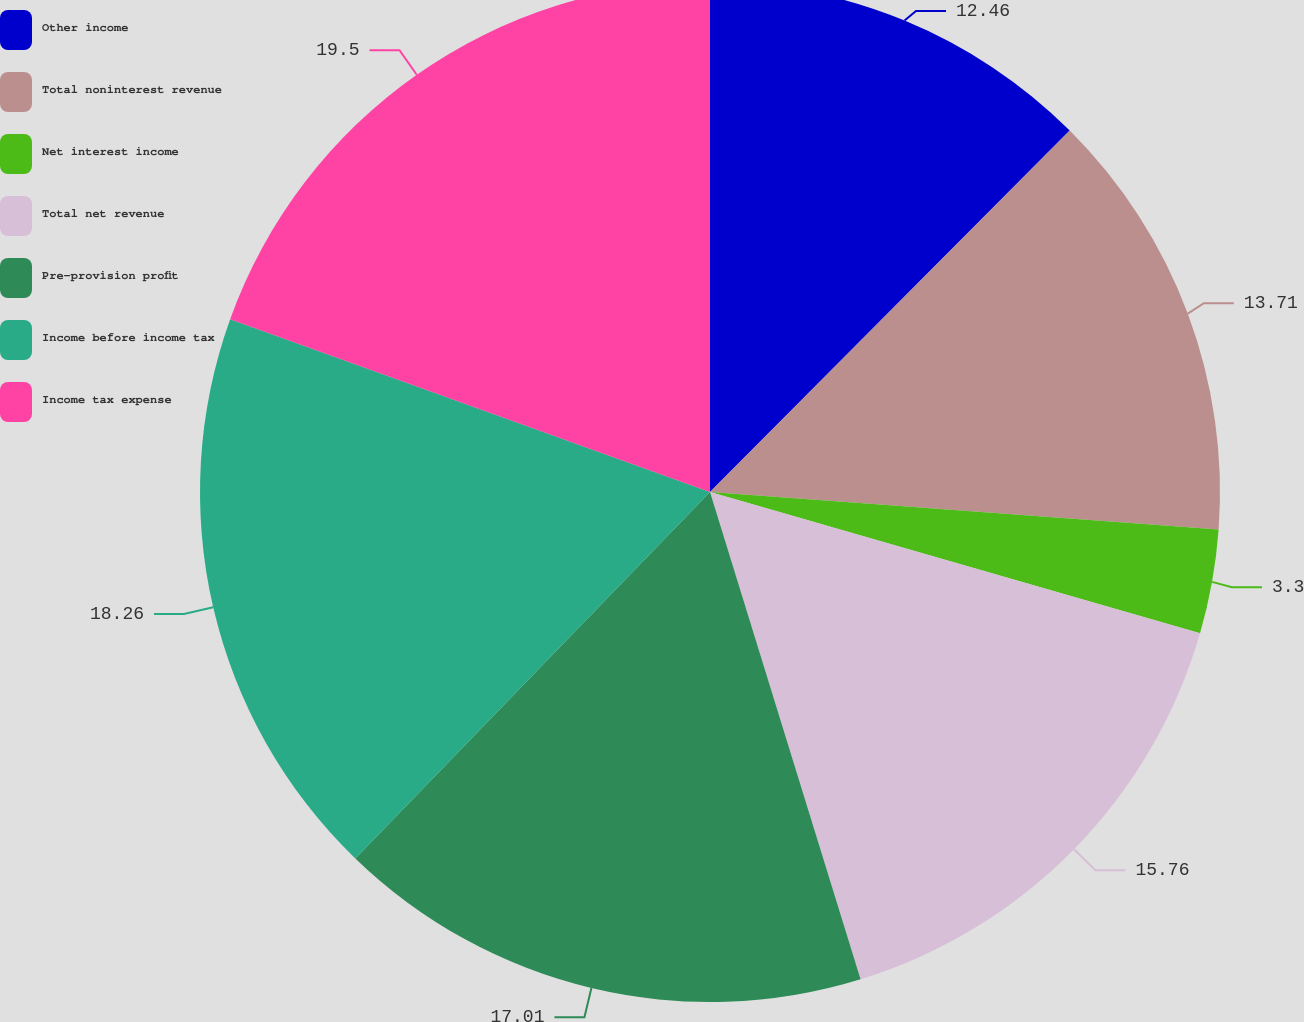<chart> <loc_0><loc_0><loc_500><loc_500><pie_chart><fcel>Other income<fcel>Total noninterest revenue<fcel>Net interest income<fcel>Total net revenue<fcel>Pre-provision profit<fcel>Income before income tax<fcel>Income tax expense<nl><fcel>12.46%<fcel>13.71%<fcel>3.3%<fcel>15.76%<fcel>17.01%<fcel>18.26%<fcel>19.5%<nl></chart> 